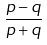<formula> <loc_0><loc_0><loc_500><loc_500>\frac { p - q } { p + q }</formula> 